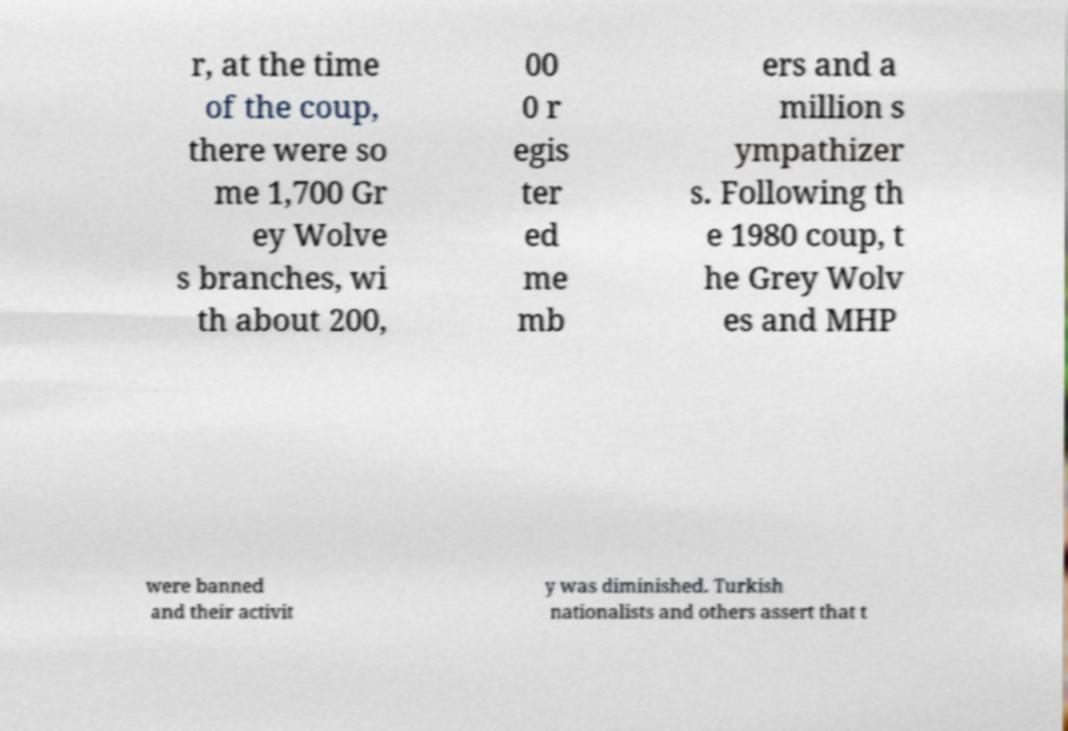Could you assist in decoding the text presented in this image and type it out clearly? r, at the time of the coup, there were so me 1,700 Gr ey Wolve s branches, wi th about 200, 00 0 r egis ter ed me mb ers and a million s ympathizer s. Following th e 1980 coup, t he Grey Wolv es and MHP were banned and their activit y was diminished. Turkish nationalists and others assert that t 